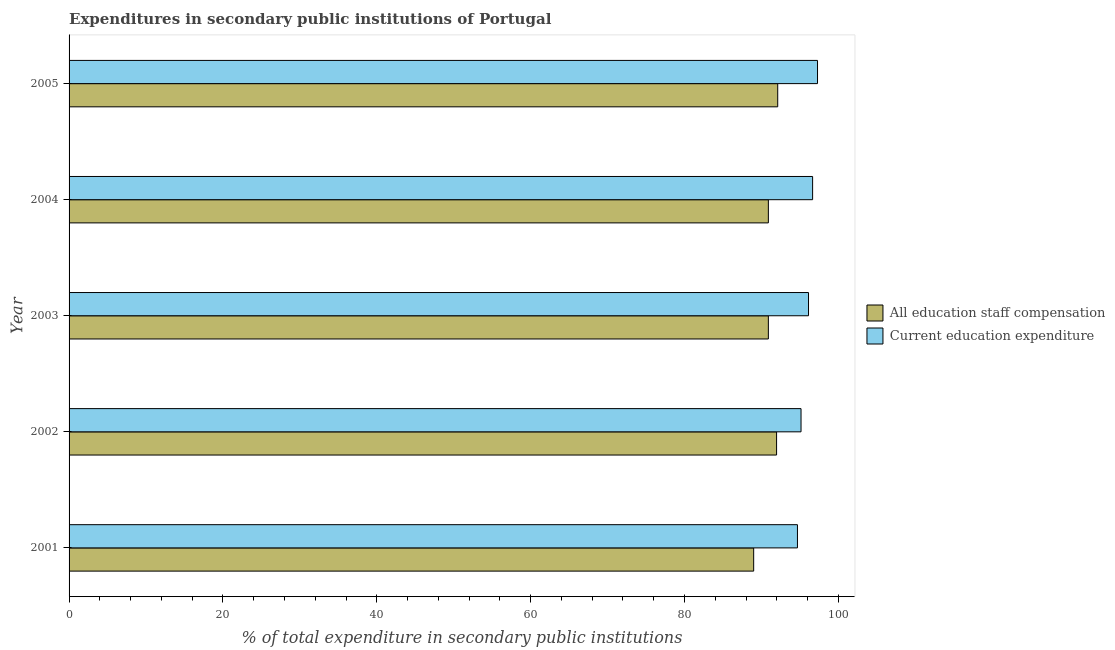How many different coloured bars are there?
Offer a terse response. 2. Are the number of bars per tick equal to the number of legend labels?
Your response must be concise. Yes. How many bars are there on the 3rd tick from the top?
Provide a succinct answer. 2. How many bars are there on the 2nd tick from the bottom?
Provide a succinct answer. 2. What is the label of the 5th group of bars from the top?
Make the answer very short. 2001. In how many cases, is the number of bars for a given year not equal to the number of legend labels?
Make the answer very short. 0. What is the expenditure in education in 2005?
Provide a short and direct response. 97.29. Across all years, what is the maximum expenditure in staff compensation?
Your response must be concise. 92.12. Across all years, what is the minimum expenditure in staff compensation?
Your response must be concise. 88.99. In which year was the expenditure in education maximum?
Your answer should be very brief. 2005. What is the total expenditure in education in the graph?
Offer a terse response. 479.88. What is the difference between the expenditure in education in 2001 and that in 2003?
Offer a terse response. -1.44. What is the difference between the expenditure in education in 2004 and the expenditure in staff compensation in 2002?
Provide a succinct answer. 4.68. What is the average expenditure in staff compensation per year?
Your answer should be compact. 90.97. In the year 2004, what is the difference between the expenditure in staff compensation and expenditure in education?
Offer a very short reply. -5.75. In how many years, is the expenditure in education greater than 92 %?
Ensure brevity in your answer.  5. What is the ratio of the expenditure in education in 2001 to that in 2002?
Your answer should be compact. 0.99. Is the difference between the expenditure in staff compensation in 2001 and 2005 greater than the difference between the expenditure in education in 2001 and 2005?
Make the answer very short. No. What is the difference between the highest and the second highest expenditure in education?
Your response must be concise. 0.64. What is the difference between the highest and the lowest expenditure in education?
Your response must be concise. 2.61. Is the sum of the expenditure in education in 2001 and 2004 greater than the maximum expenditure in staff compensation across all years?
Keep it short and to the point. Yes. What does the 2nd bar from the top in 2005 represents?
Make the answer very short. All education staff compensation. What does the 1st bar from the bottom in 2005 represents?
Offer a terse response. All education staff compensation. How many bars are there?
Your answer should be very brief. 10. What is the difference between two consecutive major ticks on the X-axis?
Your answer should be very brief. 20. Where does the legend appear in the graph?
Your response must be concise. Center right. What is the title of the graph?
Keep it short and to the point. Expenditures in secondary public institutions of Portugal. Does "Net savings(excluding particulate emission damage)" appear as one of the legend labels in the graph?
Ensure brevity in your answer.  No. What is the label or title of the X-axis?
Make the answer very short. % of total expenditure in secondary public institutions. What is the label or title of the Y-axis?
Provide a succinct answer. Year. What is the % of total expenditure in secondary public institutions of All education staff compensation in 2001?
Ensure brevity in your answer.  88.99. What is the % of total expenditure in secondary public institutions in Current education expenditure in 2001?
Give a very brief answer. 94.68. What is the % of total expenditure in secondary public institutions in All education staff compensation in 2002?
Your answer should be compact. 91.97. What is the % of total expenditure in secondary public institutions in Current education expenditure in 2002?
Offer a terse response. 95.15. What is the % of total expenditure in secondary public institutions of All education staff compensation in 2003?
Give a very brief answer. 90.9. What is the % of total expenditure in secondary public institutions of Current education expenditure in 2003?
Provide a succinct answer. 96.12. What is the % of total expenditure in secondary public institutions in All education staff compensation in 2004?
Ensure brevity in your answer.  90.9. What is the % of total expenditure in secondary public institutions of Current education expenditure in 2004?
Provide a short and direct response. 96.65. What is the % of total expenditure in secondary public institutions of All education staff compensation in 2005?
Your answer should be compact. 92.12. What is the % of total expenditure in secondary public institutions of Current education expenditure in 2005?
Give a very brief answer. 97.29. Across all years, what is the maximum % of total expenditure in secondary public institutions in All education staff compensation?
Make the answer very short. 92.12. Across all years, what is the maximum % of total expenditure in secondary public institutions in Current education expenditure?
Give a very brief answer. 97.29. Across all years, what is the minimum % of total expenditure in secondary public institutions in All education staff compensation?
Keep it short and to the point. 88.99. Across all years, what is the minimum % of total expenditure in secondary public institutions of Current education expenditure?
Make the answer very short. 94.68. What is the total % of total expenditure in secondary public institutions in All education staff compensation in the graph?
Your answer should be compact. 454.87. What is the total % of total expenditure in secondary public institutions of Current education expenditure in the graph?
Your response must be concise. 479.88. What is the difference between the % of total expenditure in secondary public institutions of All education staff compensation in 2001 and that in 2002?
Ensure brevity in your answer.  -2.98. What is the difference between the % of total expenditure in secondary public institutions in Current education expenditure in 2001 and that in 2002?
Your response must be concise. -0.47. What is the difference between the % of total expenditure in secondary public institutions in All education staff compensation in 2001 and that in 2003?
Provide a succinct answer. -1.91. What is the difference between the % of total expenditure in secondary public institutions of Current education expenditure in 2001 and that in 2003?
Offer a terse response. -1.44. What is the difference between the % of total expenditure in secondary public institutions of All education staff compensation in 2001 and that in 2004?
Provide a succinct answer. -1.91. What is the difference between the % of total expenditure in secondary public institutions in Current education expenditure in 2001 and that in 2004?
Give a very brief answer. -1.97. What is the difference between the % of total expenditure in secondary public institutions in All education staff compensation in 2001 and that in 2005?
Give a very brief answer. -3.13. What is the difference between the % of total expenditure in secondary public institutions of Current education expenditure in 2001 and that in 2005?
Provide a succinct answer. -2.61. What is the difference between the % of total expenditure in secondary public institutions of All education staff compensation in 2002 and that in 2003?
Offer a very short reply. 1.07. What is the difference between the % of total expenditure in secondary public institutions of Current education expenditure in 2002 and that in 2003?
Your response must be concise. -0.97. What is the difference between the % of total expenditure in secondary public institutions in All education staff compensation in 2002 and that in 2004?
Provide a short and direct response. 1.07. What is the difference between the % of total expenditure in secondary public institutions in Current education expenditure in 2002 and that in 2004?
Offer a very short reply. -1.5. What is the difference between the % of total expenditure in secondary public institutions of All education staff compensation in 2002 and that in 2005?
Give a very brief answer. -0.15. What is the difference between the % of total expenditure in secondary public institutions in Current education expenditure in 2002 and that in 2005?
Keep it short and to the point. -2.14. What is the difference between the % of total expenditure in secondary public institutions in All education staff compensation in 2003 and that in 2004?
Give a very brief answer. -0. What is the difference between the % of total expenditure in secondary public institutions of Current education expenditure in 2003 and that in 2004?
Your answer should be compact. -0.53. What is the difference between the % of total expenditure in secondary public institutions in All education staff compensation in 2003 and that in 2005?
Keep it short and to the point. -1.22. What is the difference between the % of total expenditure in secondary public institutions of Current education expenditure in 2003 and that in 2005?
Give a very brief answer. -1.17. What is the difference between the % of total expenditure in secondary public institutions in All education staff compensation in 2004 and that in 2005?
Ensure brevity in your answer.  -1.22. What is the difference between the % of total expenditure in secondary public institutions of Current education expenditure in 2004 and that in 2005?
Give a very brief answer. -0.64. What is the difference between the % of total expenditure in secondary public institutions of All education staff compensation in 2001 and the % of total expenditure in secondary public institutions of Current education expenditure in 2002?
Your answer should be compact. -6.16. What is the difference between the % of total expenditure in secondary public institutions in All education staff compensation in 2001 and the % of total expenditure in secondary public institutions in Current education expenditure in 2003?
Make the answer very short. -7.13. What is the difference between the % of total expenditure in secondary public institutions in All education staff compensation in 2001 and the % of total expenditure in secondary public institutions in Current education expenditure in 2004?
Provide a short and direct response. -7.66. What is the difference between the % of total expenditure in secondary public institutions of All education staff compensation in 2001 and the % of total expenditure in secondary public institutions of Current education expenditure in 2005?
Ensure brevity in your answer.  -8.3. What is the difference between the % of total expenditure in secondary public institutions in All education staff compensation in 2002 and the % of total expenditure in secondary public institutions in Current education expenditure in 2003?
Your response must be concise. -4.15. What is the difference between the % of total expenditure in secondary public institutions in All education staff compensation in 2002 and the % of total expenditure in secondary public institutions in Current education expenditure in 2004?
Ensure brevity in your answer.  -4.68. What is the difference between the % of total expenditure in secondary public institutions of All education staff compensation in 2002 and the % of total expenditure in secondary public institutions of Current education expenditure in 2005?
Give a very brief answer. -5.32. What is the difference between the % of total expenditure in secondary public institutions in All education staff compensation in 2003 and the % of total expenditure in secondary public institutions in Current education expenditure in 2004?
Provide a succinct answer. -5.75. What is the difference between the % of total expenditure in secondary public institutions of All education staff compensation in 2003 and the % of total expenditure in secondary public institutions of Current education expenditure in 2005?
Your answer should be compact. -6.39. What is the difference between the % of total expenditure in secondary public institutions in All education staff compensation in 2004 and the % of total expenditure in secondary public institutions in Current education expenditure in 2005?
Offer a very short reply. -6.39. What is the average % of total expenditure in secondary public institutions in All education staff compensation per year?
Offer a very short reply. 90.97. What is the average % of total expenditure in secondary public institutions in Current education expenditure per year?
Your response must be concise. 95.98. In the year 2001, what is the difference between the % of total expenditure in secondary public institutions in All education staff compensation and % of total expenditure in secondary public institutions in Current education expenditure?
Provide a short and direct response. -5.69. In the year 2002, what is the difference between the % of total expenditure in secondary public institutions in All education staff compensation and % of total expenditure in secondary public institutions in Current education expenditure?
Offer a terse response. -3.18. In the year 2003, what is the difference between the % of total expenditure in secondary public institutions of All education staff compensation and % of total expenditure in secondary public institutions of Current education expenditure?
Give a very brief answer. -5.22. In the year 2004, what is the difference between the % of total expenditure in secondary public institutions of All education staff compensation and % of total expenditure in secondary public institutions of Current education expenditure?
Ensure brevity in your answer.  -5.75. In the year 2005, what is the difference between the % of total expenditure in secondary public institutions of All education staff compensation and % of total expenditure in secondary public institutions of Current education expenditure?
Offer a terse response. -5.17. What is the ratio of the % of total expenditure in secondary public institutions of All education staff compensation in 2001 to that in 2002?
Offer a very short reply. 0.97. What is the ratio of the % of total expenditure in secondary public institutions of Current education expenditure in 2001 to that in 2002?
Provide a short and direct response. 1. What is the ratio of the % of total expenditure in secondary public institutions in All education staff compensation in 2001 to that in 2003?
Offer a very short reply. 0.98. What is the ratio of the % of total expenditure in secondary public institutions in Current education expenditure in 2001 to that in 2003?
Ensure brevity in your answer.  0.98. What is the ratio of the % of total expenditure in secondary public institutions of Current education expenditure in 2001 to that in 2004?
Make the answer very short. 0.98. What is the ratio of the % of total expenditure in secondary public institutions in All education staff compensation in 2001 to that in 2005?
Provide a short and direct response. 0.97. What is the ratio of the % of total expenditure in secondary public institutions in Current education expenditure in 2001 to that in 2005?
Your answer should be very brief. 0.97. What is the ratio of the % of total expenditure in secondary public institutions in All education staff compensation in 2002 to that in 2003?
Provide a short and direct response. 1.01. What is the ratio of the % of total expenditure in secondary public institutions in Current education expenditure in 2002 to that in 2003?
Keep it short and to the point. 0.99. What is the ratio of the % of total expenditure in secondary public institutions in All education staff compensation in 2002 to that in 2004?
Your answer should be very brief. 1.01. What is the ratio of the % of total expenditure in secondary public institutions of Current education expenditure in 2002 to that in 2004?
Your response must be concise. 0.98. What is the ratio of the % of total expenditure in secondary public institutions in Current education expenditure in 2002 to that in 2005?
Provide a succinct answer. 0.98. What is the ratio of the % of total expenditure in secondary public institutions of All education staff compensation in 2003 to that in 2004?
Give a very brief answer. 1. What is the ratio of the % of total expenditure in secondary public institutions in All education staff compensation in 2004 to that in 2005?
Provide a succinct answer. 0.99. What is the difference between the highest and the second highest % of total expenditure in secondary public institutions of All education staff compensation?
Your answer should be compact. 0.15. What is the difference between the highest and the second highest % of total expenditure in secondary public institutions in Current education expenditure?
Ensure brevity in your answer.  0.64. What is the difference between the highest and the lowest % of total expenditure in secondary public institutions in All education staff compensation?
Your response must be concise. 3.13. What is the difference between the highest and the lowest % of total expenditure in secondary public institutions in Current education expenditure?
Make the answer very short. 2.61. 